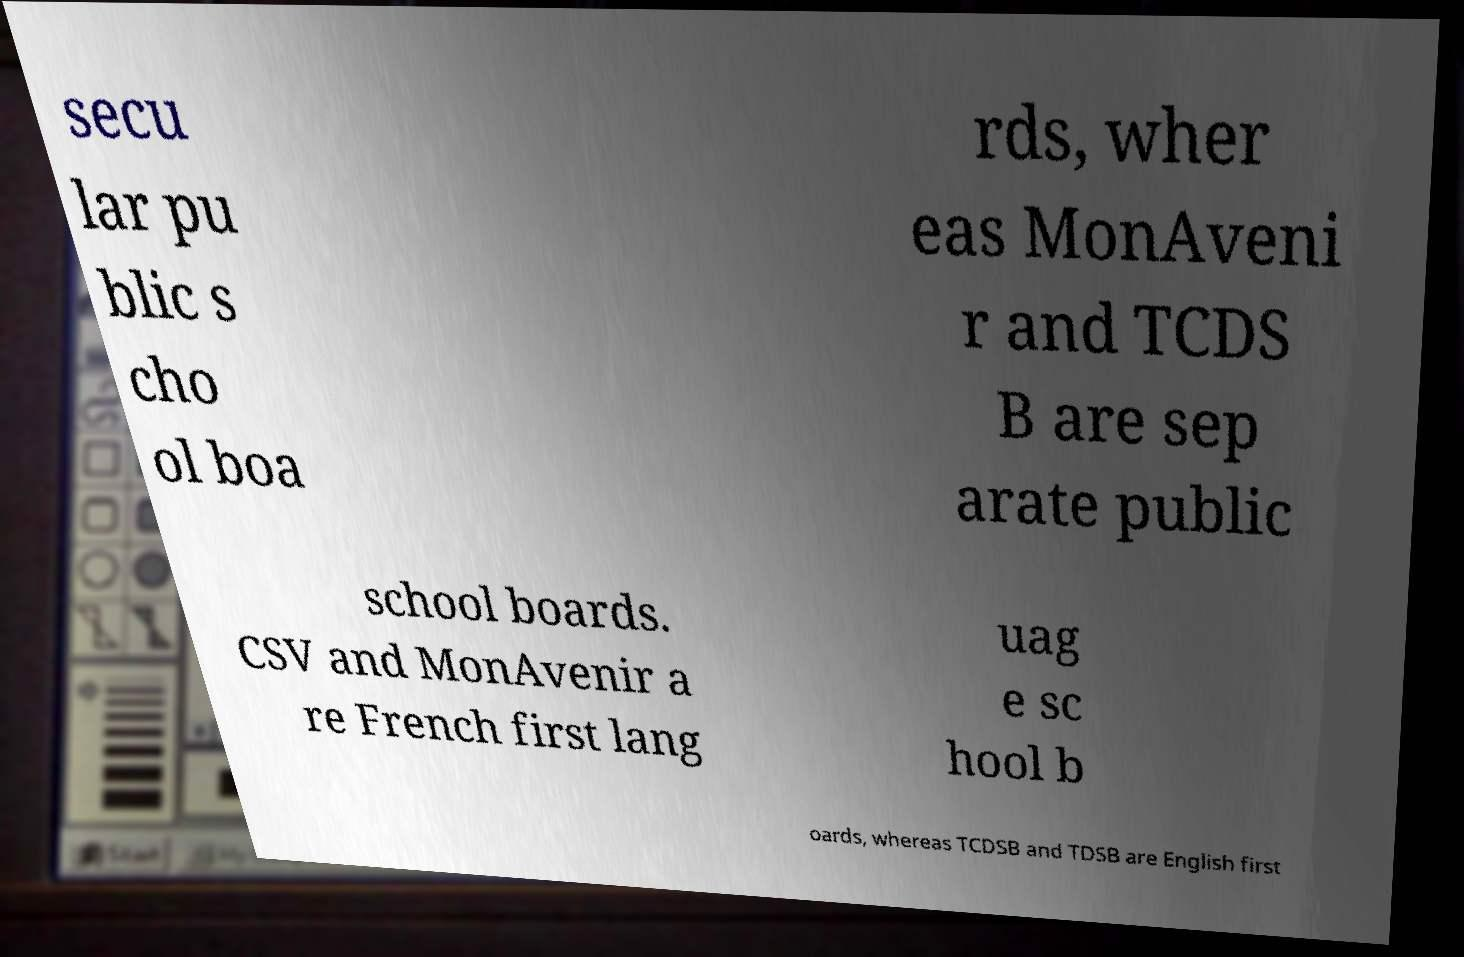What messages or text are displayed in this image? I need them in a readable, typed format. secu lar pu blic s cho ol boa rds, wher eas MonAveni r and TCDS B are sep arate public school boards. CSV and MonAvenir a re French first lang uag e sc hool b oards, whereas TCDSB and TDSB are English first 